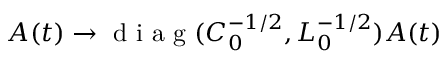<formula> <loc_0><loc_0><loc_500><loc_500>A ( t ) \rightarrow d i a g ( C _ { 0 } ^ { - 1 / 2 } , L _ { 0 } ^ { - 1 / 2 } ) A ( t )</formula> 